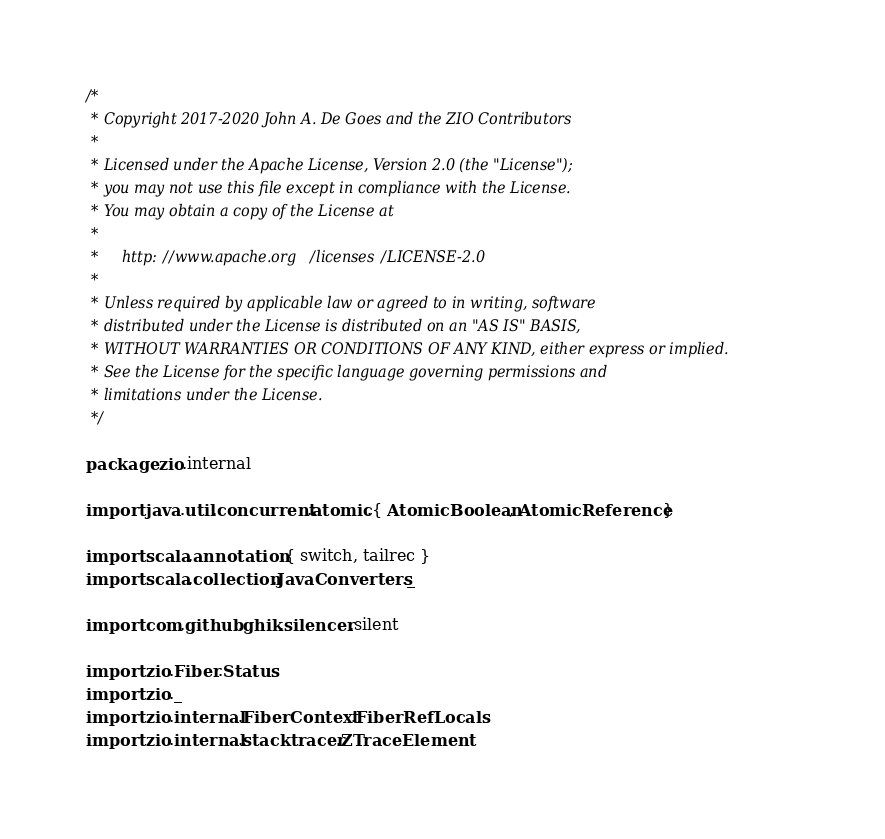<code> <loc_0><loc_0><loc_500><loc_500><_Scala_>/*
 * Copyright 2017-2020 John A. De Goes and the ZIO Contributors
 *
 * Licensed under the Apache License, Version 2.0 (the "License");
 * you may not use this file except in compliance with the License.
 * You may obtain a copy of the License at
 *
 *     http://www.apache.org/licenses/LICENSE-2.0
 *
 * Unless required by applicable law or agreed to in writing, software
 * distributed under the License is distributed on an "AS IS" BASIS,
 * WITHOUT WARRANTIES OR CONDITIONS OF ANY KIND, either express or implied.
 * See the License for the specific language governing permissions and
 * limitations under the License.
 */

package zio.internal

import java.util.concurrent.atomic.{ AtomicBoolean, AtomicReference }

import scala.annotation.{ switch, tailrec }
import scala.collection.JavaConverters._

import com.github.ghik.silencer.silent

import zio.Fiber.Status
import zio._
import zio.internal.FiberContext.FiberRefLocals
import zio.internal.stacktracer.ZTraceElement</code> 